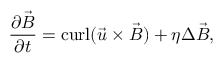Convert formula to latex. <formula><loc_0><loc_0><loc_500><loc_500>{ \frac { \partial { \vec { B } } } { \partial t } } = c u r l ( { \vec { u } } \times { \vec { B } } ) + \eta \Delta { \vec { B } } ,</formula> 